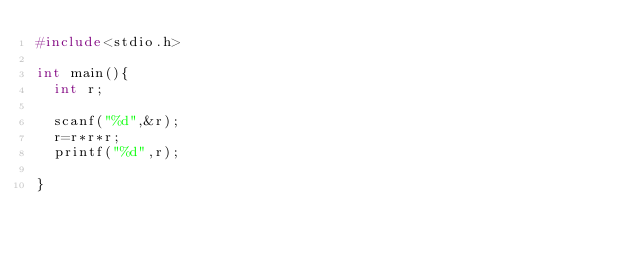<code> <loc_0><loc_0><loc_500><loc_500><_C_>#include<stdio.h>

int main(){
	int r;

	scanf("%d",&r);
	r=r*r*r;
	printf("%d",r);

}
</code> 